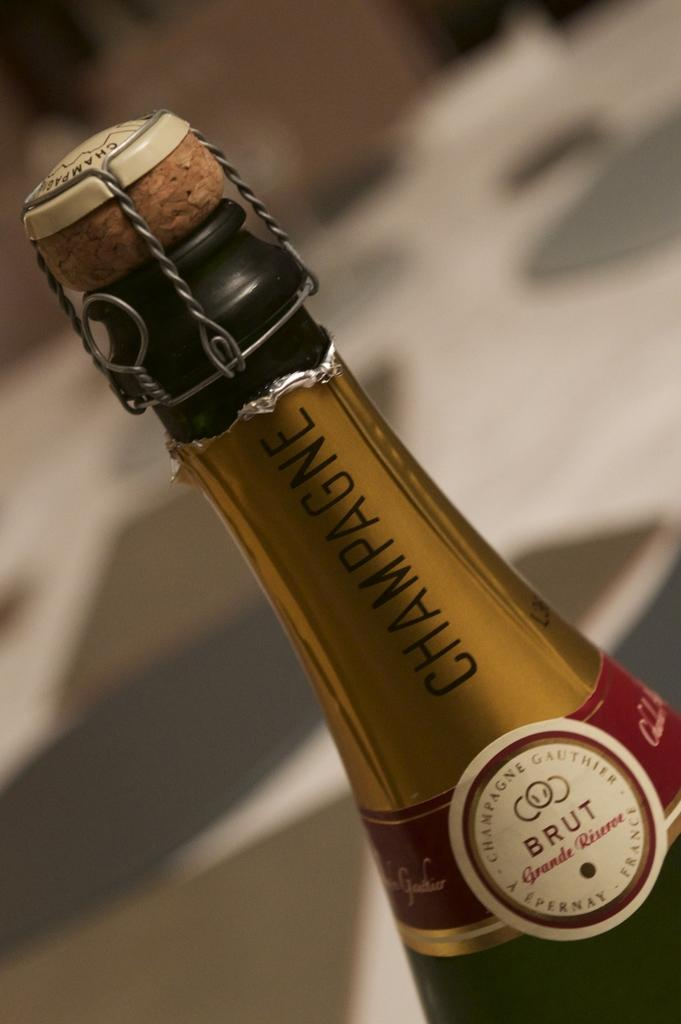<image>
Give a short and clear explanation of the subsequent image. An uncorked bottle of Brut champagne from France. 